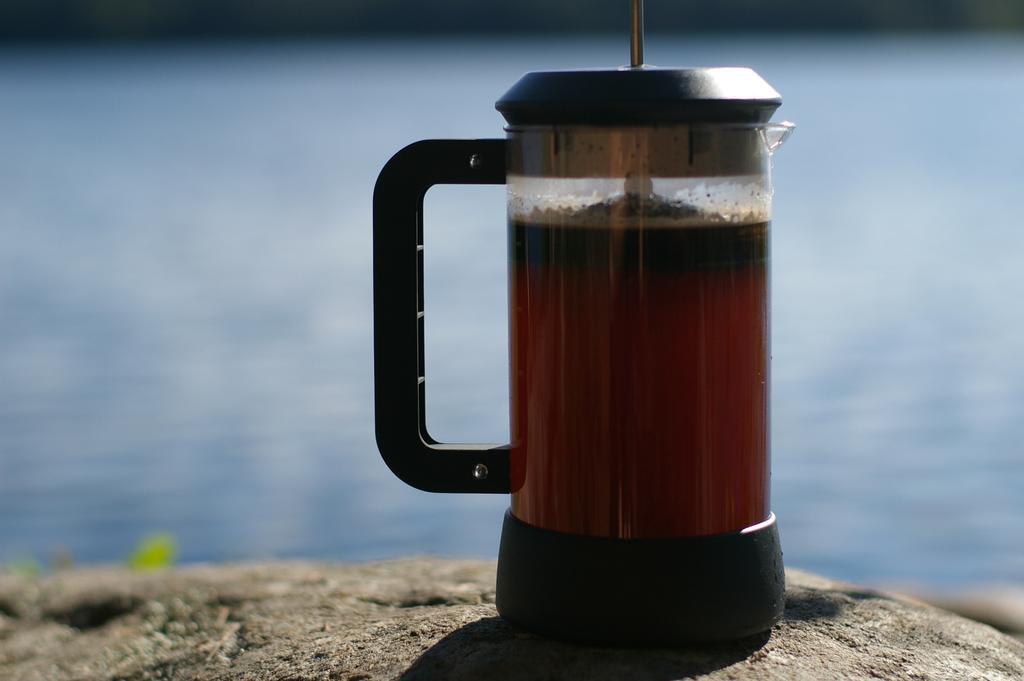In one or two sentences, can you explain what this image depicts? In this image we can see a lake. There is a juice jar on the rock surface. There is a rock at the bottom of the image. 